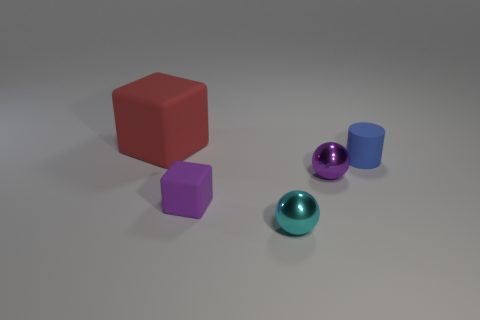Add 3 blue matte objects. How many objects exist? 8 Subtract all purple cubes. How many cubes are left? 1 Subtract all spheres. How many objects are left? 3 Subtract all gray balls. Subtract all blue blocks. How many balls are left? 2 Subtract all large cyan metal objects. Subtract all tiny blue objects. How many objects are left? 4 Add 5 big red matte things. How many big red matte things are left? 6 Add 4 small blue objects. How many small blue objects exist? 5 Subtract 0 brown cylinders. How many objects are left? 5 